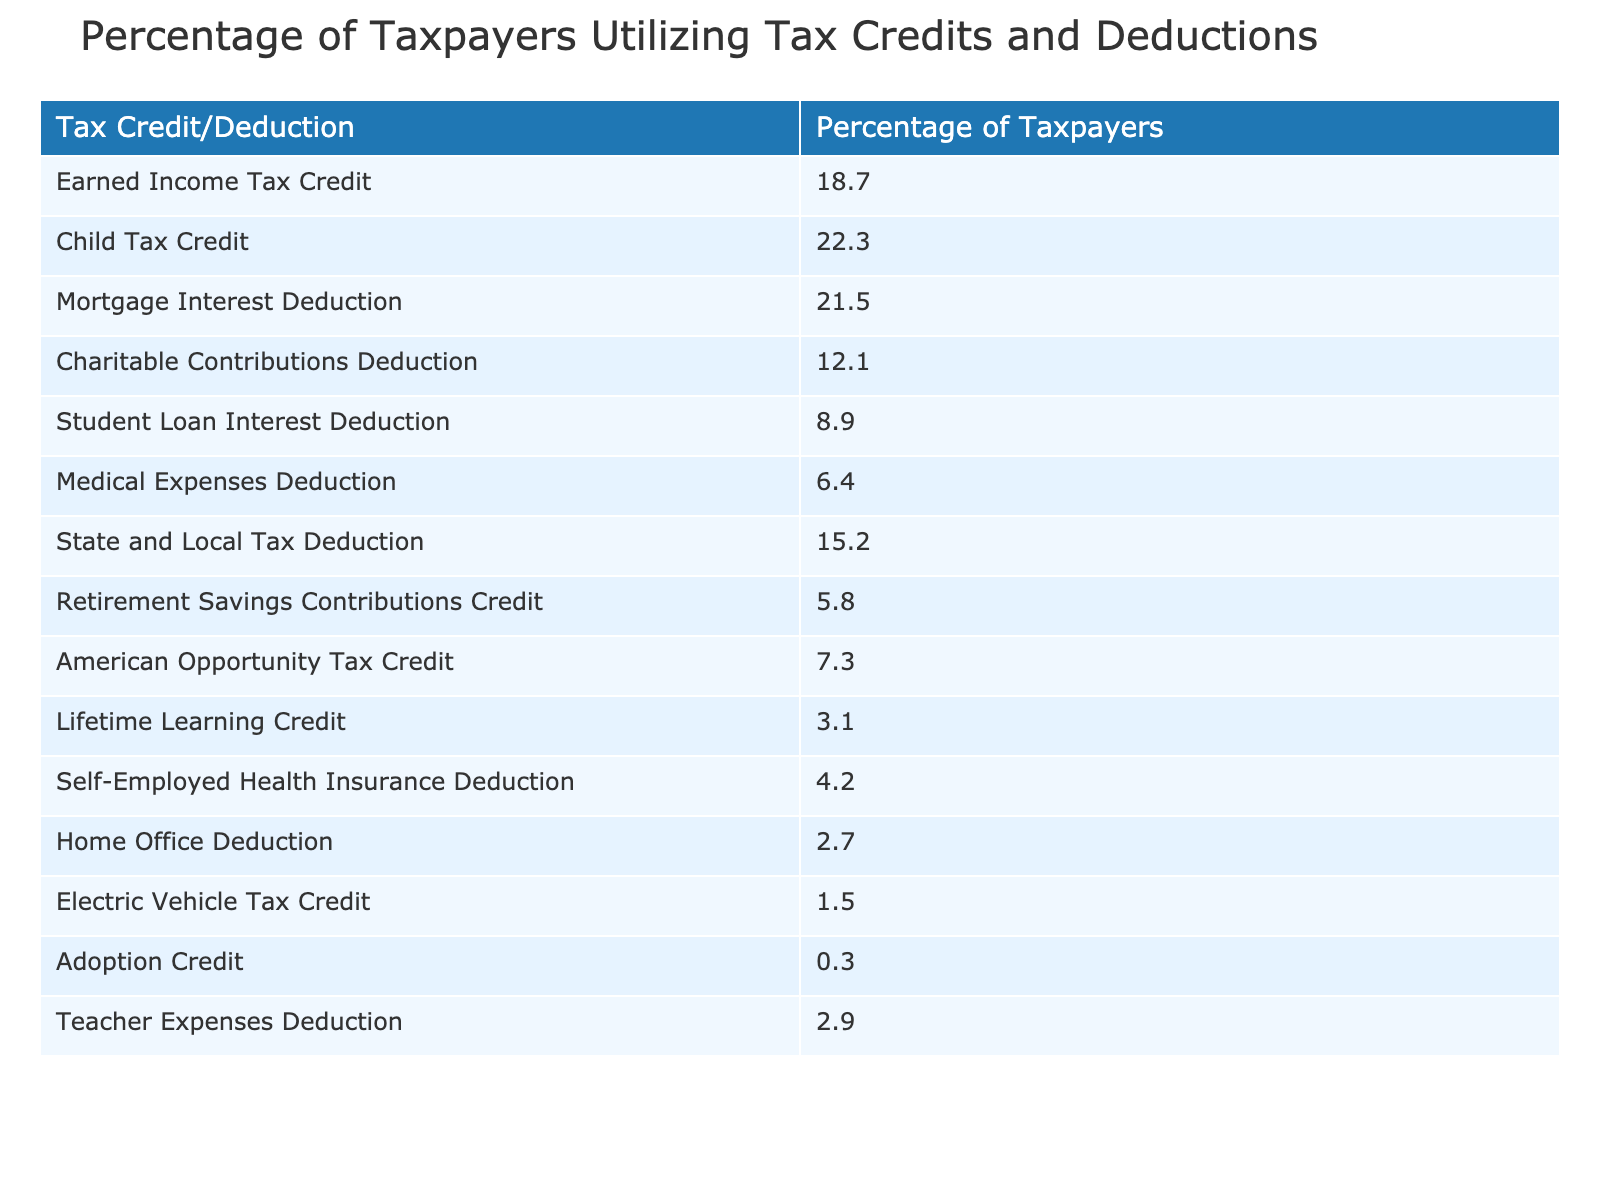What percentage of taxpayers utilized the Child Tax Credit? The table lists the percentage of taxpayers utilizing various credits, and the value for the Child Tax Credit can be directly found in the corresponding row. The percentage is 22.3%.
Answer: 22.3% Which tax credit had the lowest utilization among taxpayers? Looking at the percentages listed, the Adoption Credit shows the smallest value at 0.3%, indicating it had the lowest utilization when compared to the others in the table.
Answer: 0.3% What is the percentage of taxpayers utilizing the Mortgage Interest Deduction compared to the Medical Expenses Deduction? By checking the table, the Mortgage Interest Deduction has a utilization percentage of 21.5%, while the Medical Expenses Deduction has a percentage of 6.4%. So, we can compare these two values directly.
Answer: 21.5% versus 6.4% What is the average percentage of taxpayers utilizing all listed tax credits and deductions? To find the average, total all the percentages (sum of all listed percentages) and divide by the number of credits and deductions (15). The sum is 118.6, so the average is 118.6/15 = 7.9%.
Answer: 7.9% Did more taxpayers utilize the State and Local Tax Deduction than the Electric Vehicle Tax Credit? The State and Local Tax Deduction is utilized by 15.2% of taxpayers, while the Electric Vehicle Tax Credit is utilized by 1.5%. Since 15.2% is greater than 1.5%, we can conclude that more taxpayers utilized the former.
Answer: Yes What is the difference in utilization percentage between the Earned Income Tax Credit and the Teacher Expenses Deduction? The Earned Income Tax Credit has a utilization percentage of 18.7%, while the Teacher Expenses Deduction has a percentage of 2.9%. The difference can be calculated as 18.7% - 2.9% = 15.8%.
Answer: 15.8% How does the utilization of the Student Loan Interest Deduction compare to the American Opportunity Tax Credit in terms of taxpayer percentage? The comparison shows that the Student Loan Interest Deduction is utilized by 8.9% of taxpayers, whereas the American Opportunity Tax Credit is utilized by a lower percentage of 7.3%. Therefore, more taxpayers used the Student Loan Interest Deduction.
Answer: More taxpayers utilized the Student Loan Interest Deduction Which tax credit/deduction has a utilization percentage more than 20%? Reviewing the table, the Earned Income Tax Credit (18.7%), Child Tax Credit (22.3%), and Mortgage Interest Deduction (21.5%) can be checked to see which exceed 20%. So, the Child Tax Credit and Mortgage Interest Deduction meet this criterion.
Answer: Child Tax Credit and Mortgage Interest Deduction Is the sum of taxpayers utilizing the Retirement Savings Contributions Credit and the Home Office Deduction greater than 10%? The Retirement Savings Contributions Credit has 5.8%, and the Home Office Deduction has 2.7%. Adding these together gives 5.8% + 2.7% = 8.5%, which is less than 10%.
Answer: No 